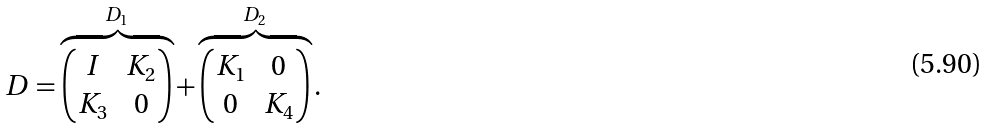<formula> <loc_0><loc_0><loc_500><loc_500>D = \overbrace { \begin{pmatrix} I & K _ { 2 } \\ K _ { 3 } & 0 \\ \end{pmatrix} } ^ { D _ { 1 } } + \overbrace { \begin{pmatrix} K _ { 1 } & 0 \\ 0 & K _ { 4 } \\ \end{pmatrix} } ^ { D _ { 2 } } .</formula> 